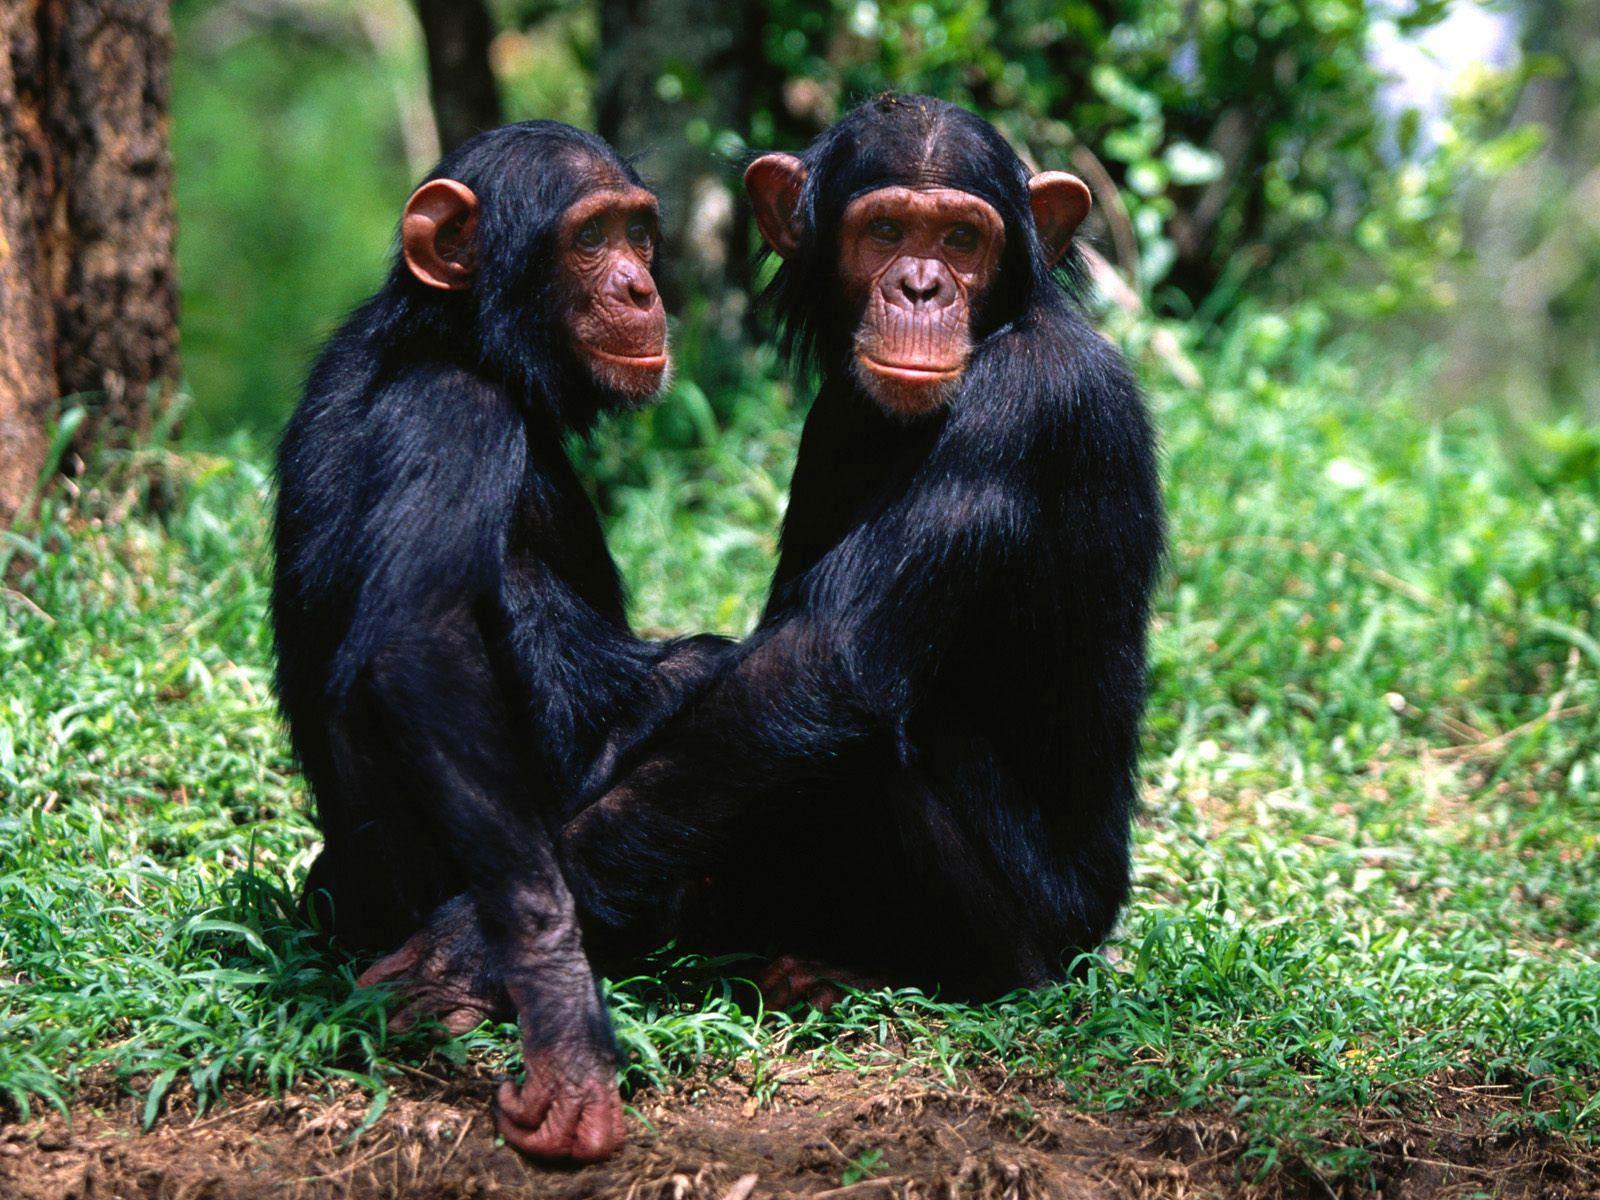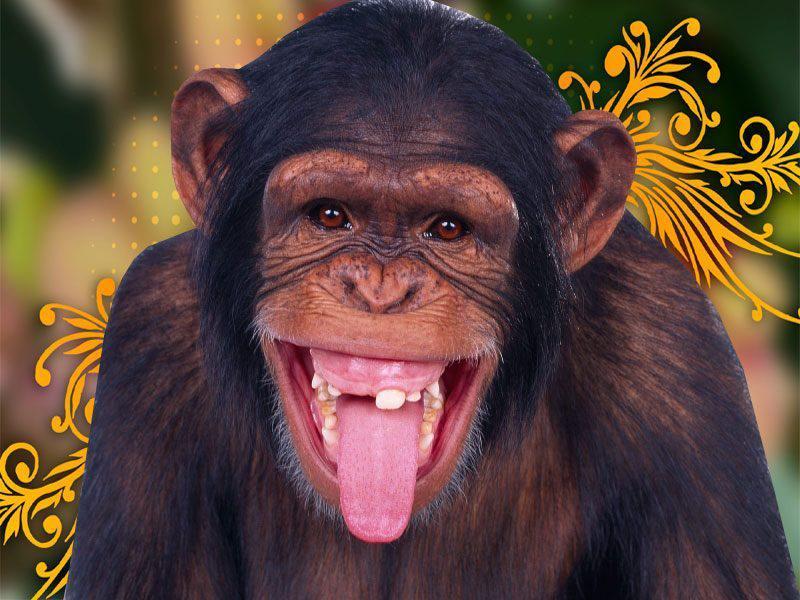The first image is the image on the left, the second image is the image on the right. Analyze the images presented: Is the assertion "One of the image features more than one monkey." valid? Answer yes or no. Yes. The first image is the image on the left, the second image is the image on the right. Examine the images to the left and right. Is the description "There are only two monkeys." accurate? Answer yes or no. No. 